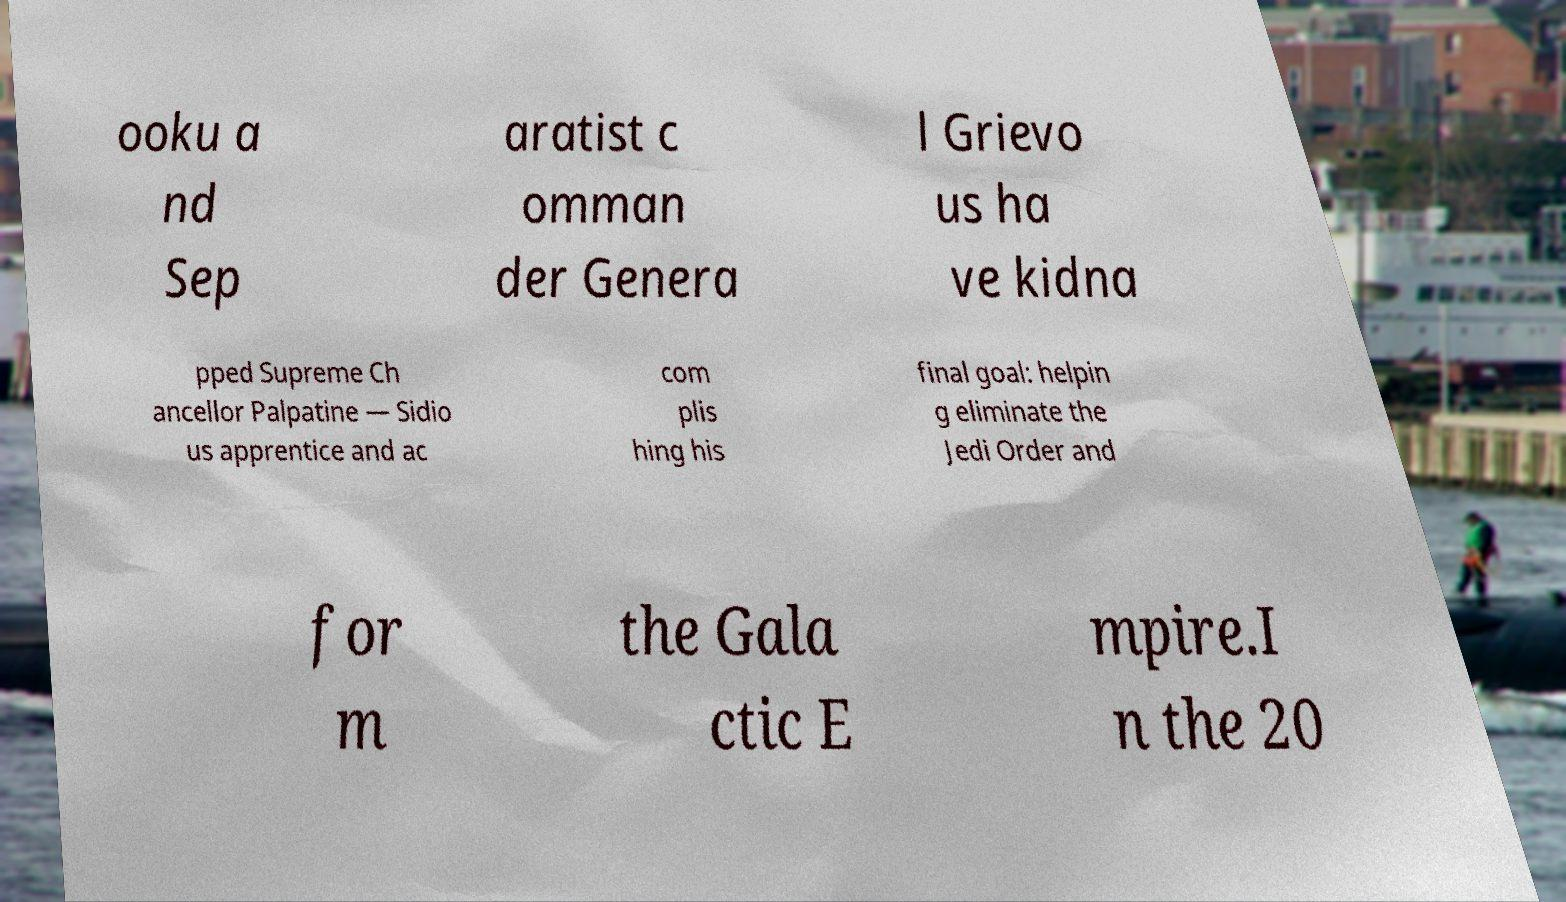Please identify and transcribe the text found in this image. ooku a nd Sep aratist c omman der Genera l Grievo us ha ve kidna pped Supreme Ch ancellor Palpatine — Sidio us apprentice and ac com plis hing his final goal: helpin g eliminate the Jedi Order and for m the Gala ctic E mpire.I n the 20 